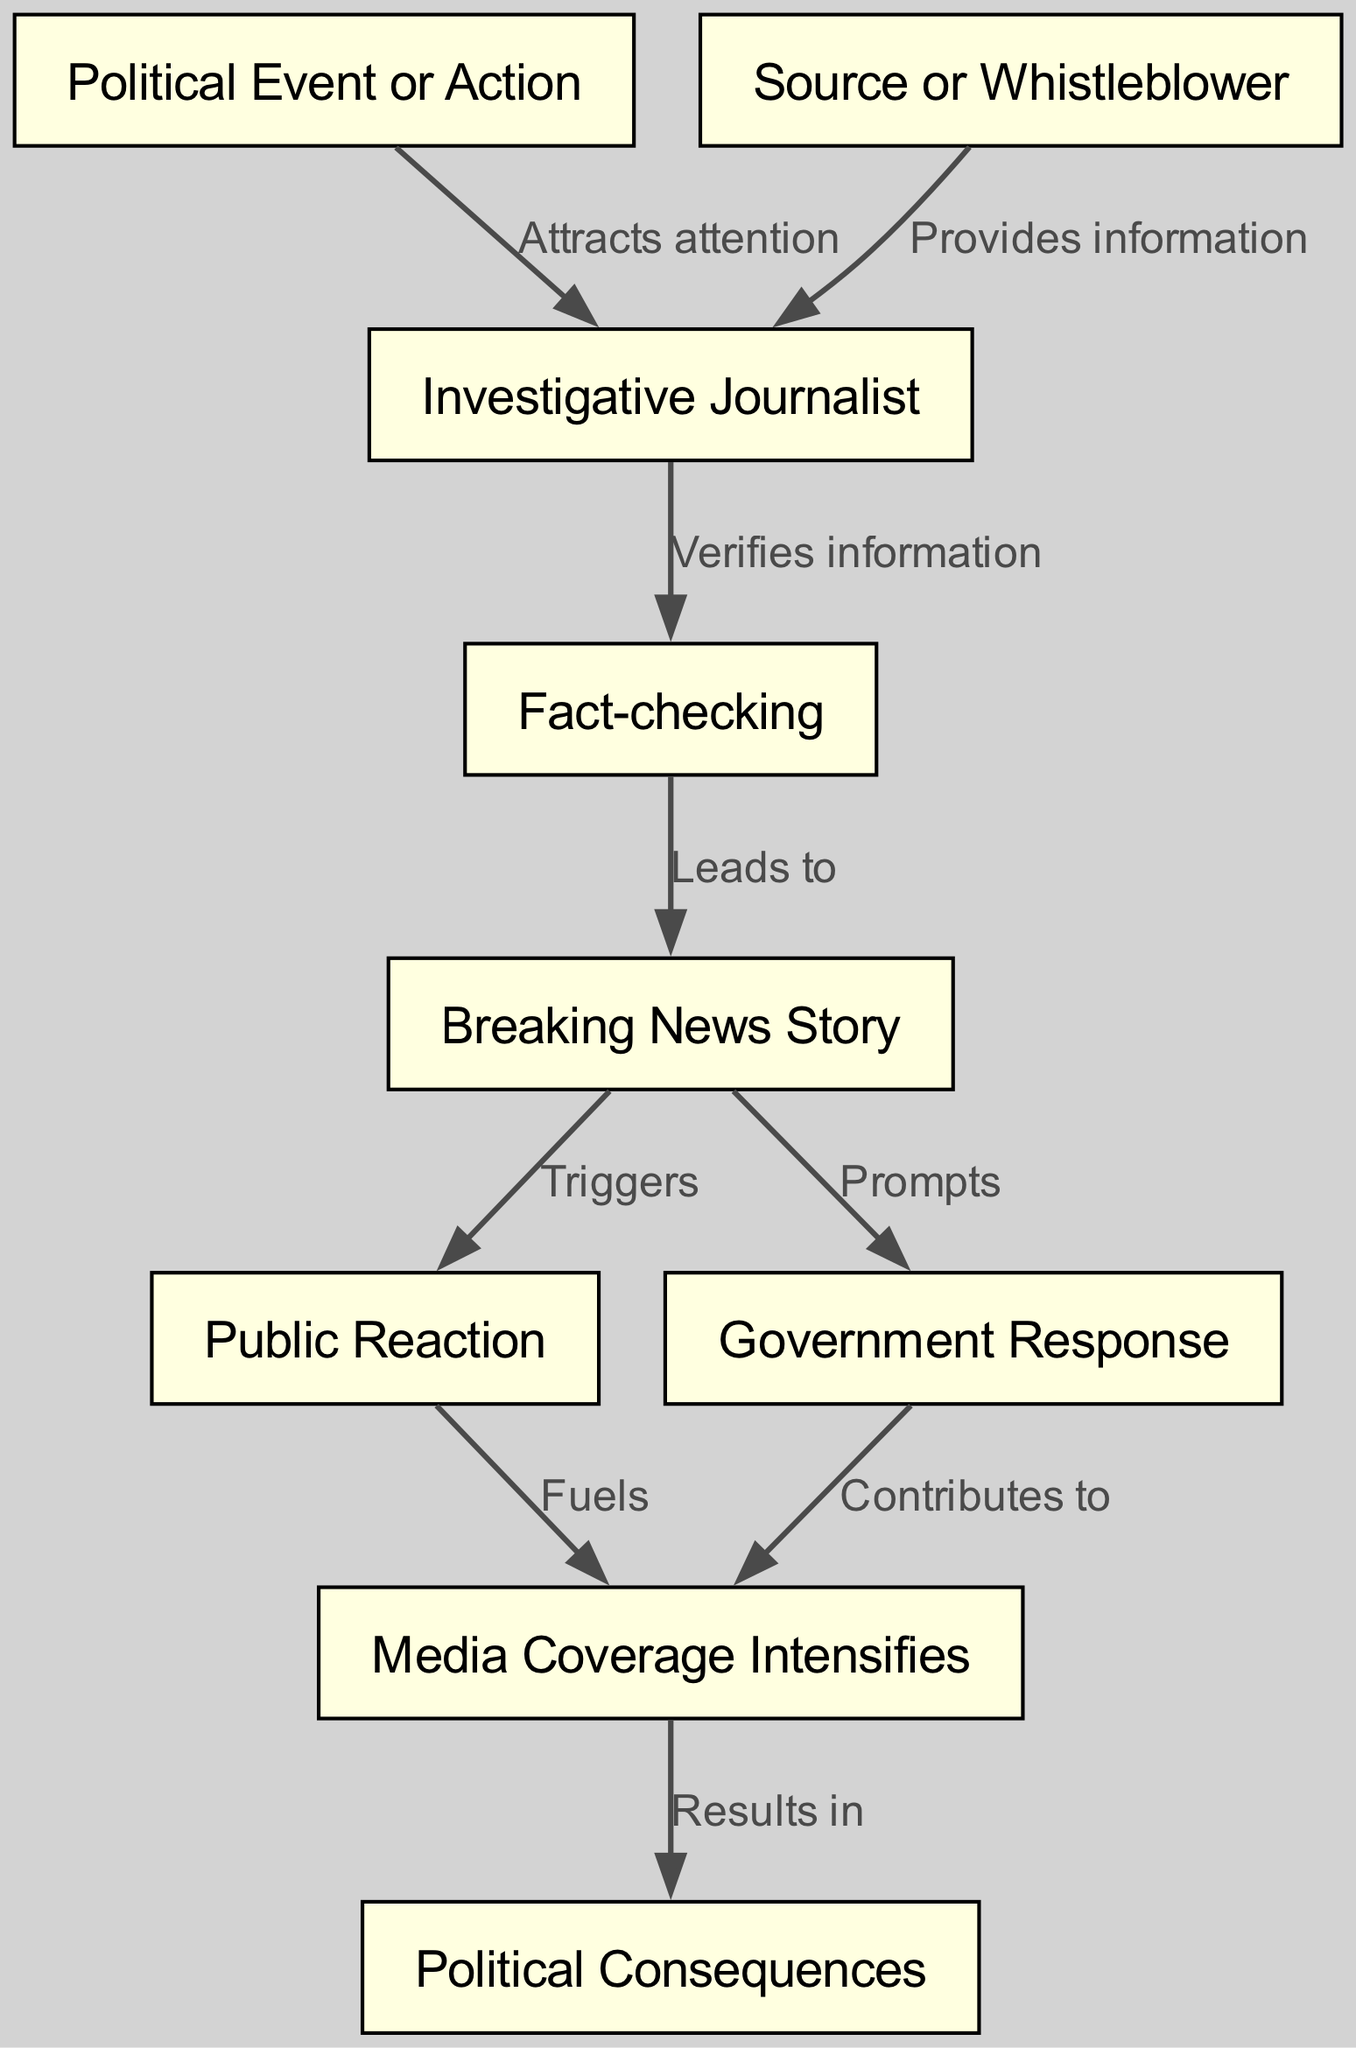What is the first node in the diagram? The first node is the starting point of the flow chart, which is the "Political Event or Action" node.
Answer: Political Event or Action How many nodes are in the diagram? The diagram contains a total of nine distinct nodes representing various steps in the process of a political scandal.
Answer: 9 Which node leads to the "Breaking News Story"? The "Fact-checking" node is directly connected to the "Breaking News Story," indicating that it verifies the information before the news is published.
Answer: Fact-checking What action does the "Investigative Journalist" take after gathering information? The "Investigative Journalist" verifies the information received from the source or whistleblower before proceeding to publish the news.
Answer: Verifies information Which two nodes contribute to the "Media Coverage Intensifies"? The "Public Reaction" and the "Government Response" nodes both lead into the "Media Coverage Intensifies," indicating that both public and governmental actions fuel media attention.
Answer: Public Reaction and Government Response What is the result of "Media Coverage Intensifies"? The increased media coverage ultimately results in "Political Consequences," which signifies the potential outcomes or impacts as a result of the scandal being publicized.
Answer: Political Consequences Which relationship indicates that a source provides information? The relationship between the "Source or Whistleblower" and the "Investigative Journalist" depicts this connection, emphasizing the importance of receiving information from the source.
Answer: Provides information What triggers the "Public Reaction"? The "Breaking News Story" acts as the trigger for the public reaction, indicating that when news breaks out, it prompts the public to respond.
Answer: Triggers What role does "Fact-checking" play in the flow? "Fact-checking" serves as a verification step that leads directly to the creation of the "Breaking News Story," ensuring the information is accurate before publication.
Answer: Leads to 